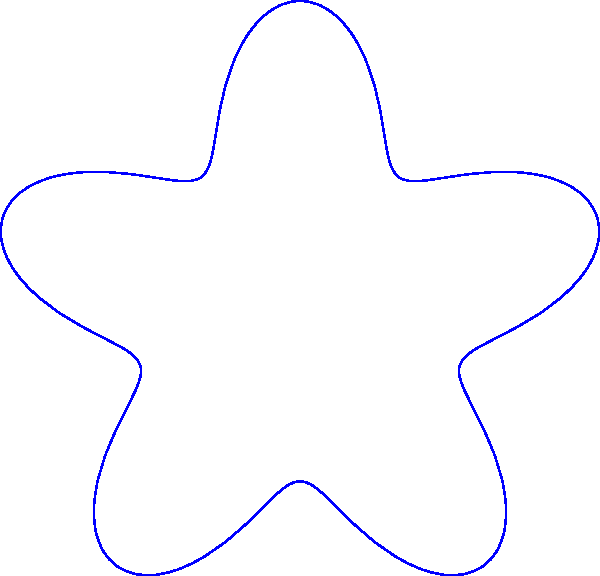In the polar coordinate representation of a baseball strike zone shown above, the boundary is given by the equation $r = 1 + 0.3\sin(5\theta)$. At which angle $\theta$ does the strike zone extend furthest from the origin? To find the angle where the strike zone extends furthest from the origin, we need to follow these steps:

1) The distance from the origin is given by the radius $r$, which is a function of $\theta$:
   $r(\theta) = 1 + 0.3\sin(5\theta)$

2) To find the maximum value of $r$, we need to find where $\sin(5\theta)$ is at its maximum.

3) The sine function reaches its maximum value of 1 when its argument is $\frac{\pi}{2}$ (or 90°).

4) So, we need to solve the equation:
   $5\theta = \frac{\pi}{2}$

5) Solving for $\theta$:
   $\theta = \frac{\pi}{10}$

6) This is the first angle where $r$ reaches its maximum. Due to the periodicity of the sine function, this will repeat every $\frac{2\pi}{5}$ radians.

7) The angles where $r$ is maximum are:
   $\frac{\pi}{10}$, $\frac{\pi}{10} + \frac{2\pi}{5}$, $\frac{\pi}{10} + \frac{4\pi}{5}$, $\frac{\pi}{10} + \frac{6\pi}{5}$, $\frac{\pi}{10} + \frac{8\pi}{5}$

8) These simplify to:
   $\frac{\pi}{10}$, $\frac{\pi}{2}$, $\frac{9\pi}{10}$, $\frac{13\pi}{10}$, $\frac{17\pi}{10}$

9) The question asks for one angle, so we can provide the first one: $\frac{\pi}{10}$.
Answer: $\frac{\pi}{10}$ radians 